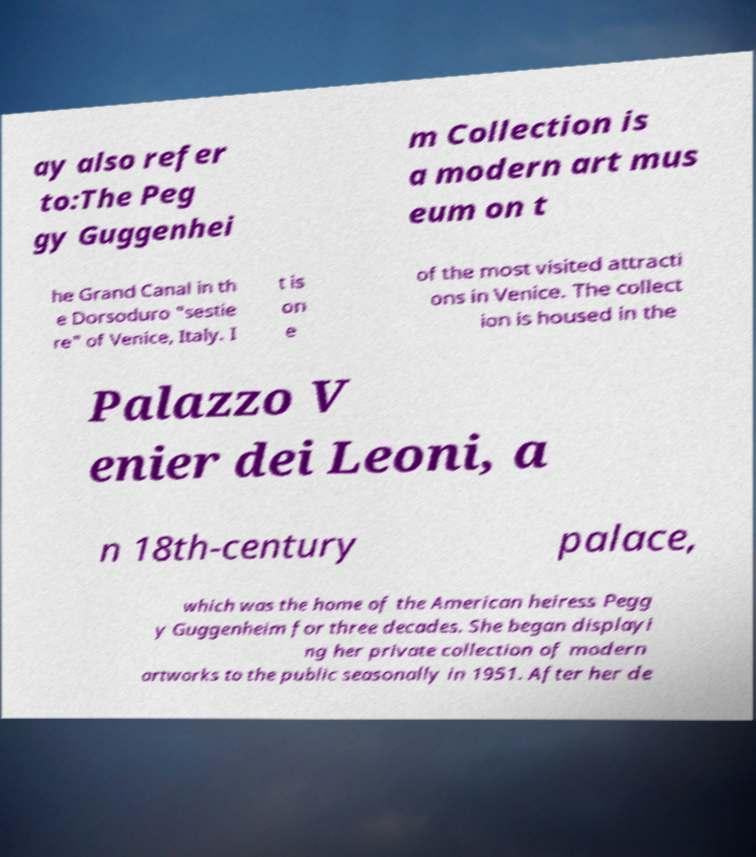I need the written content from this picture converted into text. Can you do that? ay also refer to:The Peg gy Guggenhei m Collection is a modern art mus eum on t he Grand Canal in th e Dorsoduro "sestie re" of Venice, Italy. I t is on e of the most visited attracti ons in Venice. The collect ion is housed in the Palazzo V enier dei Leoni, a n 18th-century palace, which was the home of the American heiress Pegg y Guggenheim for three decades. She began displayi ng her private collection of modern artworks to the public seasonally in 1951. After her de 